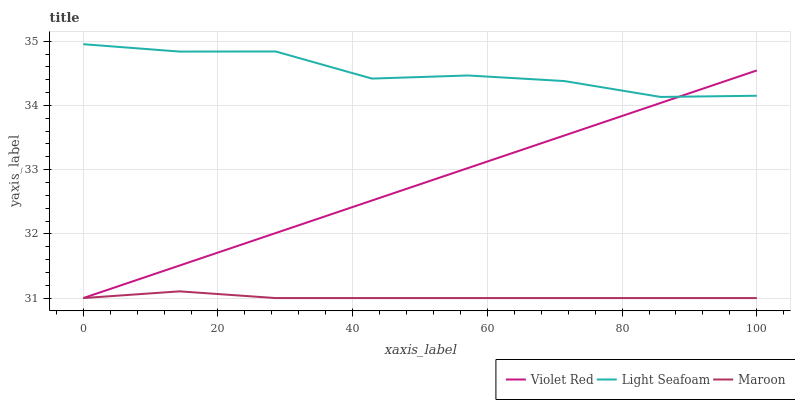Does Maroon have the minimum area under the curve?
Answer yes or no. Yes. Does Light Seafoam have the maximum area under the curve?
Answer yes or no. Yes. Does Light Seafoam have the minimum area under the curve?
Answer yes or no. No. Does Maroon have the maximum area under the curve?
Answer yes or no. No. Is Violet Red the smoothest?
Answer yes or no. Yes. Is Light Seafoam the roughest?
Answer yes or no. Yes. Is Maroon the smoothest?
Answer yes or no. No. Is Maroon the roughest?
Answer yes or no. No. Does Violet Red have the lowest value?
Answer yes or no. Yes. Does Light Seafoam have the lowest value?
Answer yes or no. No. Does Light Seafoam have the highest value?
Answer yes or no. Yes. Does Maroon have the highest value?
Answer yes or no. No. Is Maroon less than Light Seafoam?
Answer yes or no. Yes. Is Light Seafoam greater than Maroon?
Answer yes or no. Yes. Does Violet Red intersect Light Seafoam?
Answer yes or no. Yes. Is Violet Red less than Light Seafoam?
Answer yes or no. No. Is Violet Red greater than Light Seafoam?
Answer yes or no. No. Does Maroon intersect Light Seafoam?
Answer yes or no. No. 